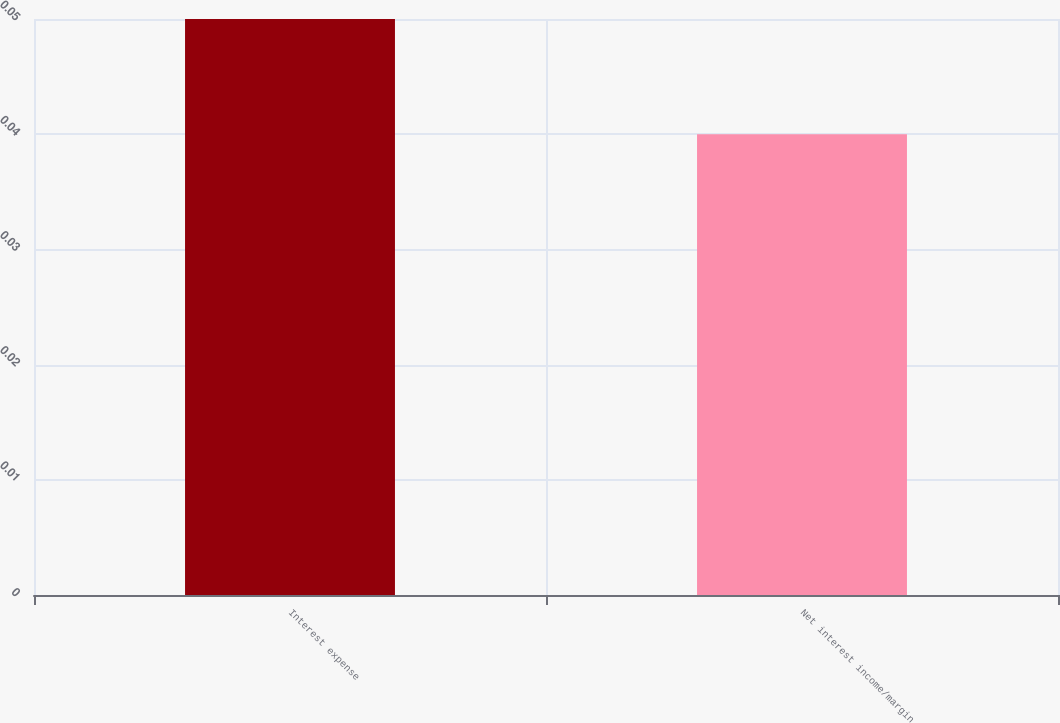Convert chart to OTSL. <chart><loc_0><loc_0><loc_500><loc_500><bar_chart><fcel>Interest expense<fcel>Net interest income/margin<nl><fcel>0.05<fcel>0.04<nl></chart> 